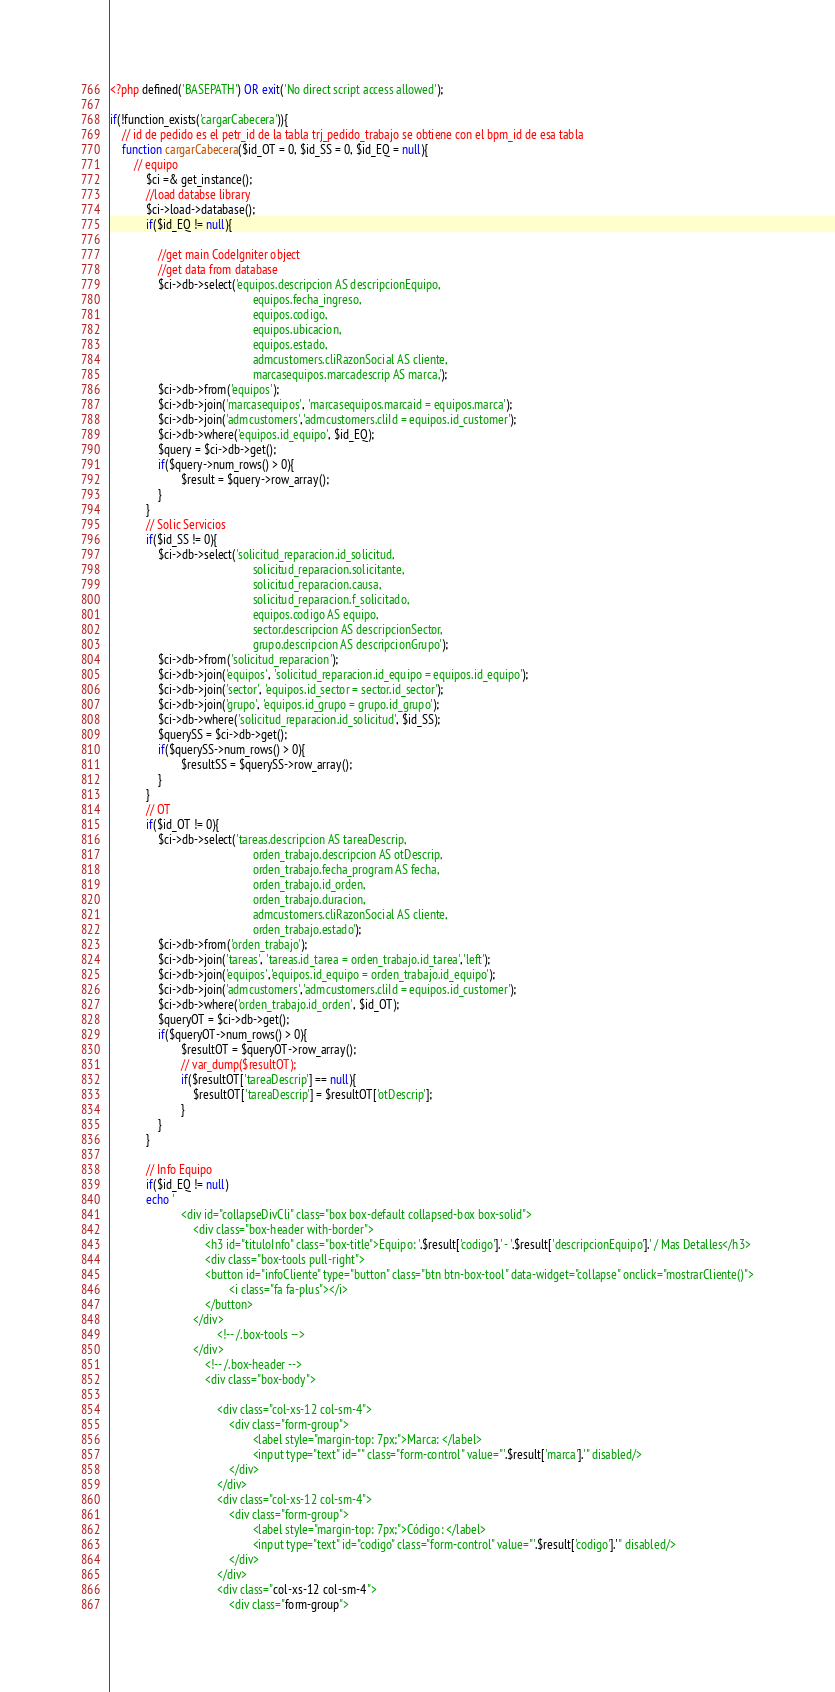Convert code to text. <code><loc_0><loc_0><loc_500><loc_500><_PHP_><?php defined('BASEPATH') OR exit('No direct script access allowed');

if(!function_exists('cargarCabecera')){
    // id de pedido es el petr_id de la tabla trj_pedido_trabajo se obtiene con el bpm_id de esa tabla
    function cargarCabecera($id_OT = 0, $id_SS = 0, $id_EQ = null){
		// equipo
			$ci =& get_instance();			
			//load databse library
			$ci->load->database();			
			if($id_EQ != null){
				
				//get main CodeIgniter object
				//get data from database		
				$ci->db->select('equipos.descripcion AS descripcionEquipo,
												equipos.fecha_ingreso,												
												equipos.codigo,
												equipos.ubicacion,
												equipos.estado,
												admcustomers.cliRazonSocial AS cliente,
												marcasequipos.marcadescrip AS marca,');	
				$ci->db->from('equipos');	
				$ci->db->join('marcasequipos', 'marcasequipos.marcaid = equipos.marca');	
				$ci->db->join('admcustomers','admcustomers.cliId = equipos.id_customer');	
				$ci->db->where('equipos.id_equipo', $id_EQ);
				$query = $ci->db->get();			
				if($query->num_rows() > 0){
						$result = $query->row_array();
				}
			}
			// Solic Servicios			
			if($id_SS != 0){
				$ci->db->select('solicitud_reparacion.id_solicitud,
												solicitud_reparacion.solicitante,
												solicitud_reparacion.causa,
												solicitud_reparacion.f_solicitado,
												equipos.codigo AS equipo,
												sector.descripcion AS descripcionSector,
												grupo.descripcion AS descripcionGrupo');	
				$ci->db->from('solicitud_reparacion');
				$ci->db->join('equipos', 'solicitud_reparacion.id_equipo = equipos.id_equipo');
				$ci->db->join('sector', 'equipos.id_sector = sector.id_sector');
				$ci->db->join('grupo', 'equipos.id_grupo = grupo.id_grupo');			
				$ci->db->where('solicitud_reparacion.id_solicitud', $id_SS);
				$querySS = $ci->db->get();			
				if($querySS->num_rows() > 0){
						$resultSS = $querySS->row_array();
				}
			}	
			// OT
			if($id_OT != 0){
				$ci->db->select('tareas.descripcion AS tareaDescrip,
												orden_trabajo.descripcion AS otDescrip,
												orden_trabajo.fecha_program AS fecha,
												orden_trabajo.id_orden,
												orden_trabajo.duracion,
												admcustomers.cliRazonSocial AS cliente,
												orden_trabajo.estado');	
				$ci->db->from('orden_trabajo');		
				$ci->db->join('tareas', 'tareas.id_tarea = orden_trabajo.id_tarea','left');		
				$ci->db->join('equipos','equipos.id_equipo = orden_trabajo.id_equipo');
				$ci->db->join('admcustomers','admcustomers.cliId = equipos.id_customer');	
				$ci->db->where('orden_trabajo.id_orden', $id_OT);
				$queryOT = $ci->db->get();			
				if($queryOT->num_rows() > 0){
						$resultOT = $queryOT->row_array();
						// var_dump($resultOT);
						if($resultOT['tareaDescrip'] == null){
							$resultOT['tareaDescrip'] = $resultOT['otDescrip'];
						}
				}
			}		

			// Info Equipo 
			if($id_EQ != null)
			echo '        
						<div id="collapseDivCli" class="box box-default collapsed-box box-solid">
							<div class="box-header with-border">
								<h3 id="tituloInfo" class="box-title">Equipo: '.$result['codigo'].' - '.$result['descripcionEquipo'].' / Mas Detalles</h3>
								<div class="box-tools pull-right">
								<button id="infoCliente" type="button" class="btn btn-box-tool" data-widget="collapse" onclick="mostrarCliente()">
										<i class="fa fa-plus"></i>
								</button>
							</div>
									<!-- /.box-tools -->
							</div>
								<!-- /.box-header -->
								<div class="box-body">
										
									<div class="col-xs-12 col-sm-4">
										<div class="form-group">
												<label style="margin-top: 7px;">Marca: </label>
												<input type="text" id="" class="form-control" value="'.$result['marca'].'" disabled/>
										</div>						
									</div>
									<div class="col-xs-12 col-sm-4">
										<div class="form-group">
												<label style="margin-top: 7px;">Código: </label>
												<input type="text" id="codigo" class="form-control" value="'.$result['codigo'].'" disabled/>
										</div>
									</div>
									<div class="col-xs-12 col-sm-4">
										<div class="form-group"></code> 